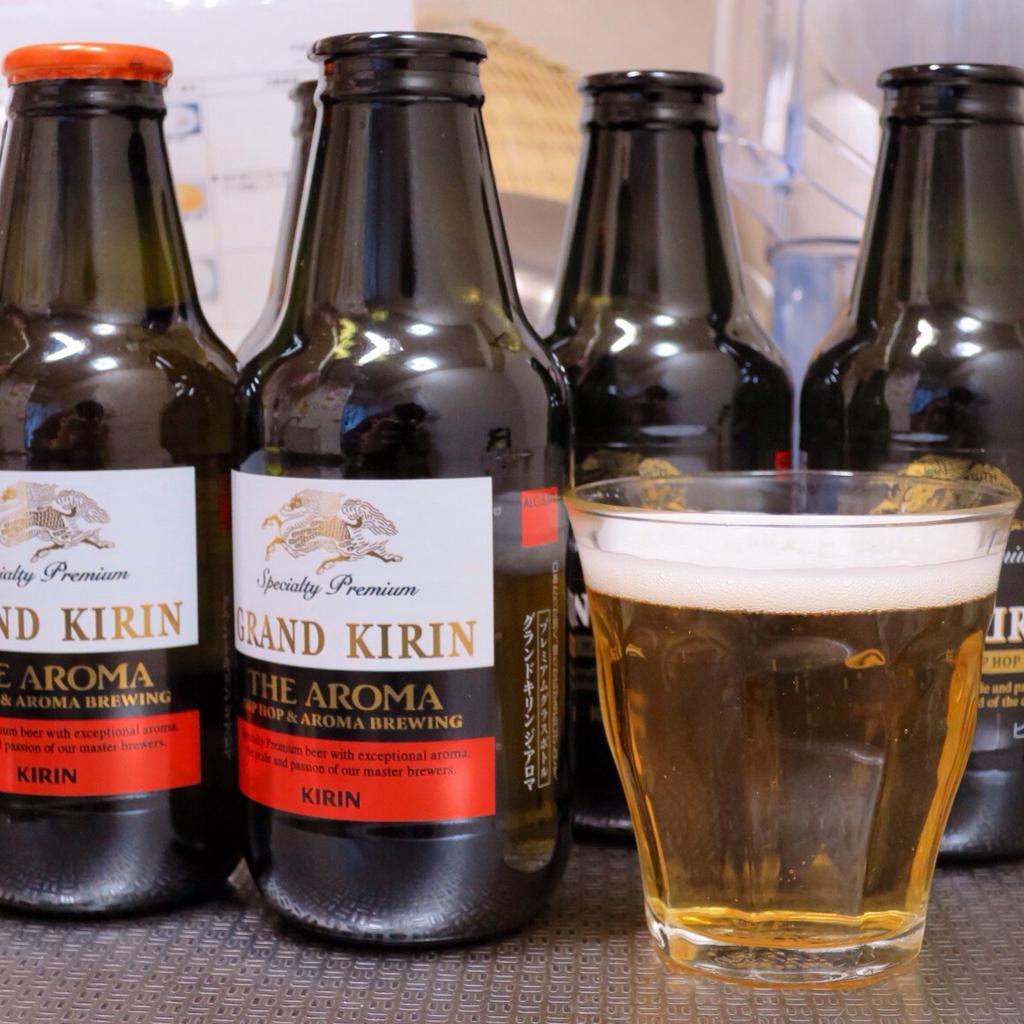What is the brand name of this beer?
Keep it short and to the point. Grand kirin. 